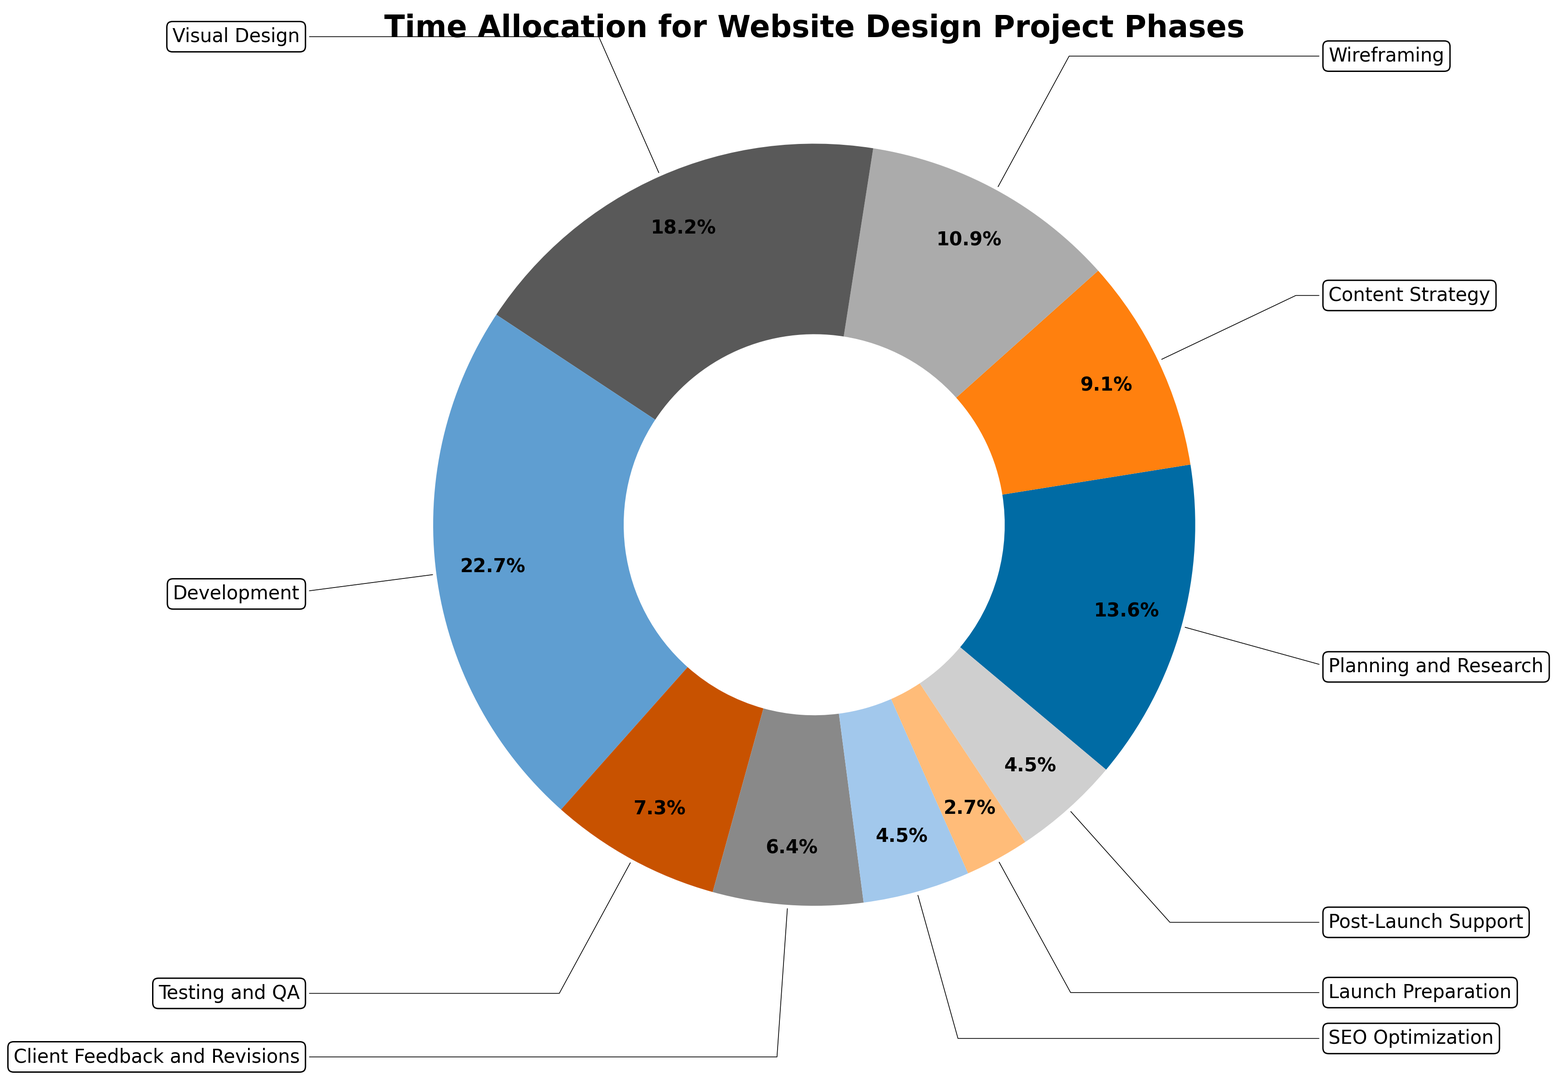What percentage of the project is dedicated to both Development and Visual Design combined? To find the combined percentage of Development and Visual Design, sum the two percentages. Development is 25% and Visual Design is 20%, so their combined percentage is 25 + 20 = 45%.
Answer: 45% Which phase has the smallest percentage allocation? To determine the smallest percentage allocation, compare all the percentages given. The phase with the smallest value is Launch Preparation at 3%.
Answer: Launch Preparation How much larger is the time allocated to Development compared to Testing and QA? To find the difference, subtract the percentage of Testing and QA from Development. Development is 25%, and Testing and QA is 8%, so the difference is 25 - 8 = 17%.
Answer: 17% What is the total percentage of the project phases with more than 10% allocation each? To find the total, add up the percentages of phases that have more than 10%. These phases are Development (25%), Visual Design (20%), Planning and Research (15%), and Wireframing (12%). The total is 25 + 20 + 15 + 12 = 72%.
Answer: 72% Which phase takes up twice as much time as SEO Optimization? To find the phase that takes up twice as much time, double the percentage of SEO Optimization and look for the match. SEO Optimization is 5%, so twice that is 10%. The phase with 10% is Content Strategy.
Answer: Content Strategy Between Wireframing and Testing and QA, which phase consumes more time and by how much? Compare the percentages of Wireframing and Testing and QA. Wireframing is 12%, and Testing and QA is 8%. The difference is 12 - 8 = 4%.
Answer: Wireframing by 4% What is the ratio of the percentage allocation of Planning and Research to Content Strategy? The percentage for Planning and Research is 15%, and for Content Strategy, it is 10%. The ratio is calculated by dividing the two percentages: 15 / 10 = 1.5.
Answer: 1.5 If Post-Launch Support and SEO Optimization were combined into one phase, what percentage of the project would their total be? To find the combined percentage, add Post-Launch Support and SEO Optimization. The values are 5% each, so 5 + 5 = 10%.
Answer: 10% 